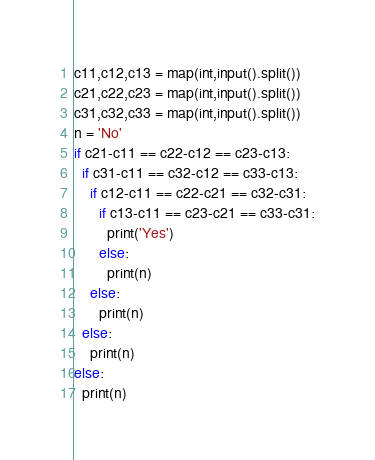<code> <loc_0><loc_0><loc_500><loc_500><_Python_>c11,c12,c13 = map(int,input().split())
c21,c22,c23 = map(int,input().split())
c31,c32,c33 = map(int,input().split())
n = 'No'
if c21-c11 == c22-c12 == c23-c13:
  if c31-c11 == c32-c12 == c33-c13:
    if c12-c11 == c22-c21 == c32-c31:
      if c13-c11 == c23-c21 == c33-c31:
        print('Yes')
      else:
        print(n)
    else:
      print(n)
  else:
    print(n)
else:
  print(n)</code> 